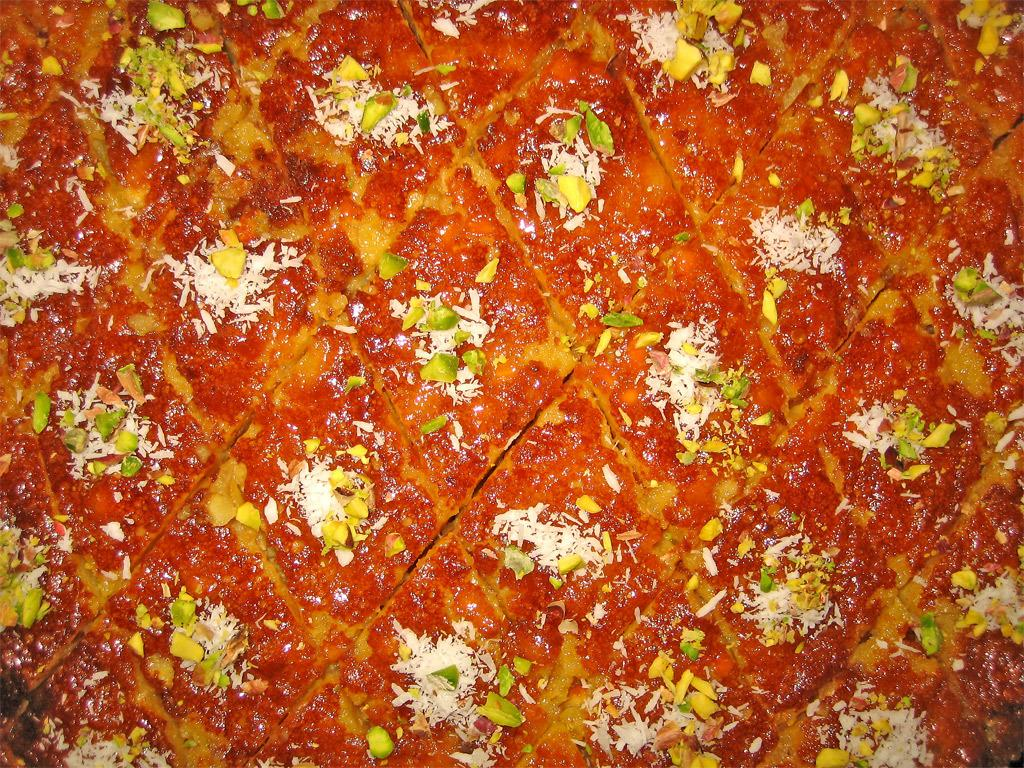What type of food can be seen in the image? There is a food item in the image, but the specific type cannot be determined from the facts provided. What colors are present in the food item? The food item has orange, yellow, green, and white colors. How is the food item cut or prepared? The food item is sliced into diamond-shaped pieces. What type of religion is being practiced in the image? There is no indication of any religious practice or symbol in the image. How many sparks can be seen coming from the food item in the image? There are no sparks present in the image. 